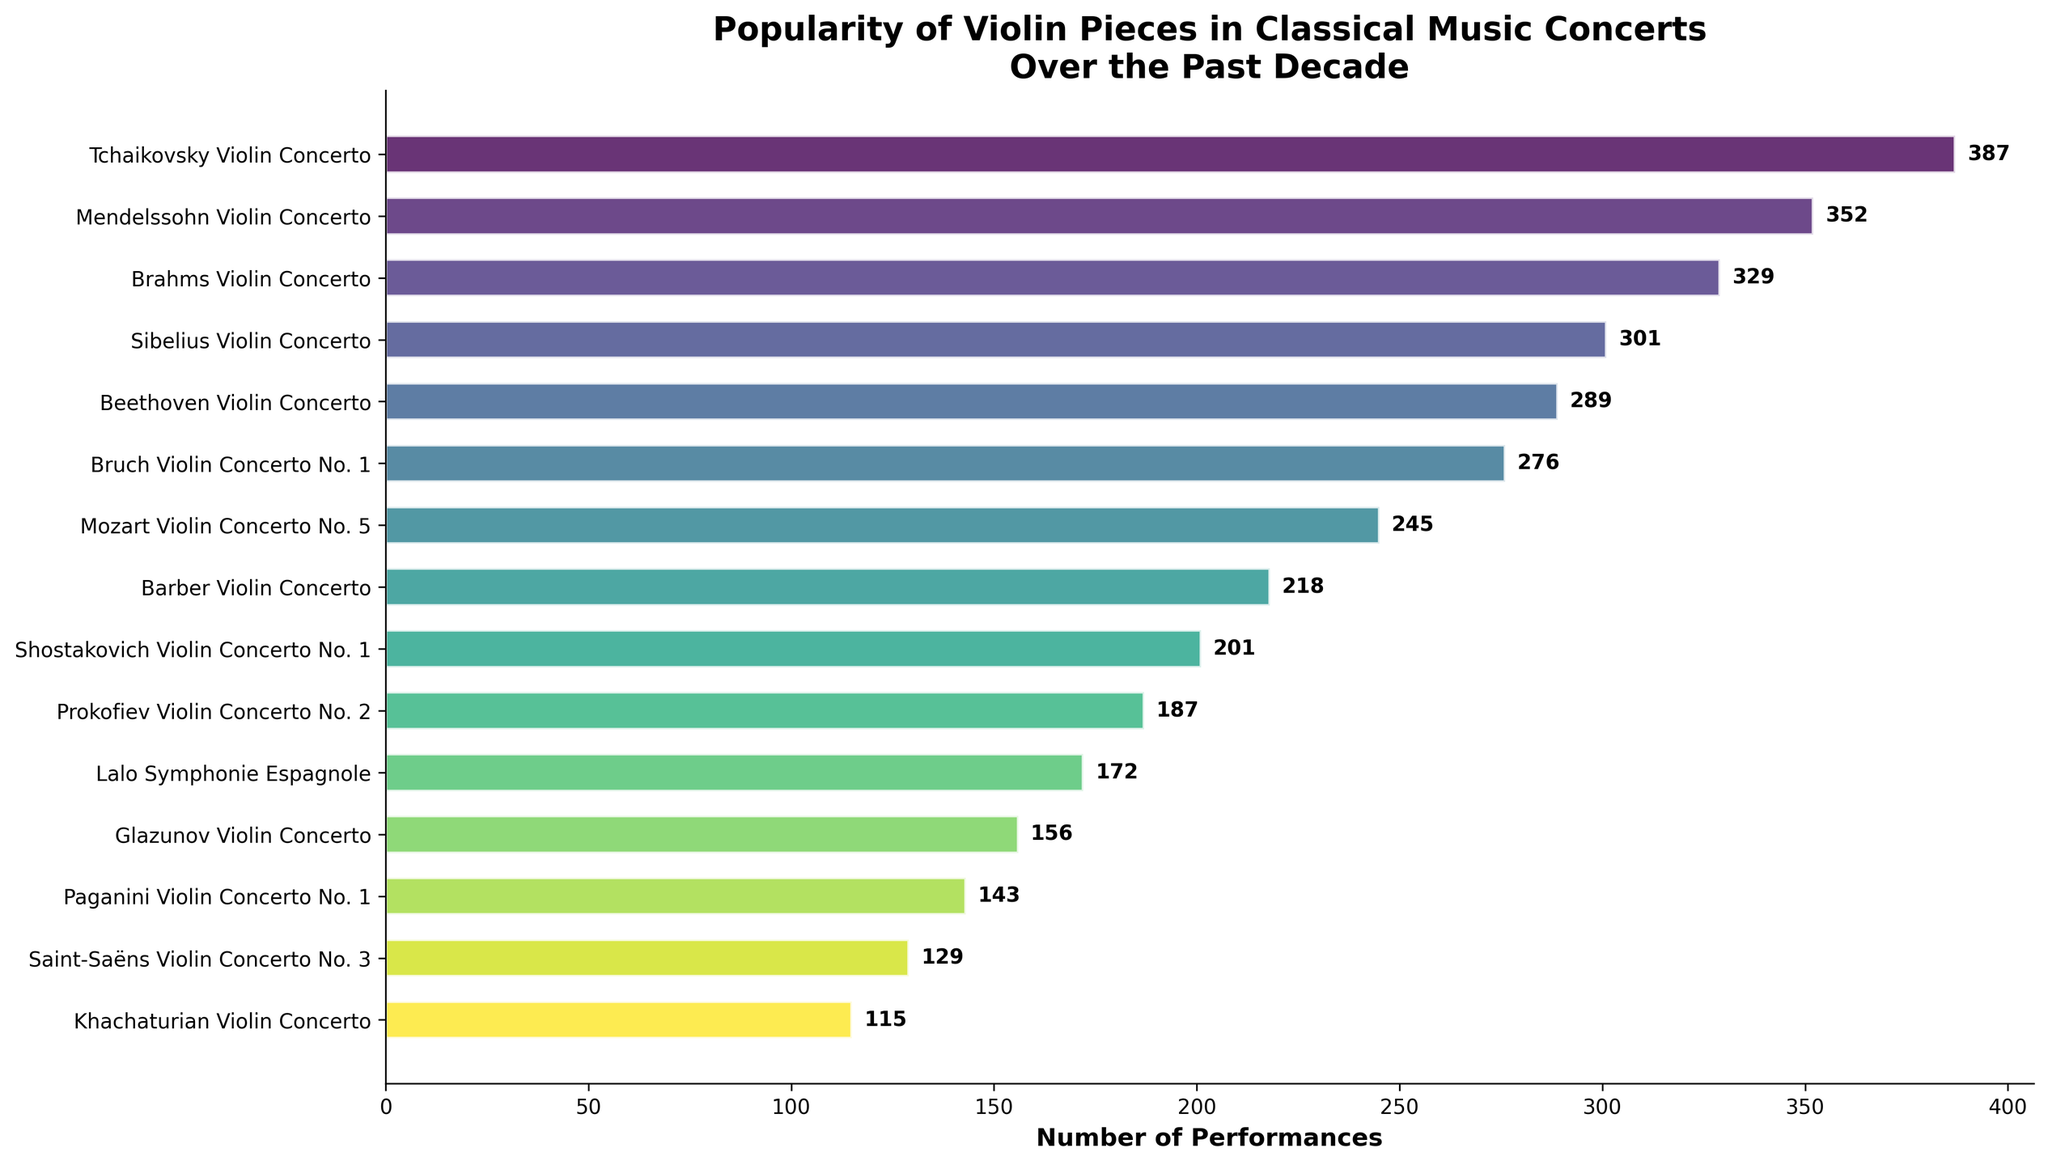What's the total number of performances for the top 3 most popular pieces? Sum the number of performances for the Tchaikovsky, Mendelssohn, and Brahms Violin Concertos: 387 + 352 + 329 = 1068
Answer: 1068 Which piece had the fewest performances? The piece with the fewest performances is the one at the bottom of the bar chart with the shortest bar. The Khachaturian Violin Concerto has the fewest performances.
Answer: Khachaturian Violin Concerto How many more performances does the Tchaikovsky Violin Concerto have compared to the Beethoven Violin Concerto? Subtract the number of performances of the Beethoven Violin Concerto from the Tchaikovsky Violin Concerto: 387 - 289 = 98
Answer: 98 What is the average number of performances of the listed pieces? Sum all the number of performances and then divide by the total number of pieces. The sum is 387 + 352 + 329 + 301 + 289 + 276 + 245 + 218 + 201 + 187 + 172 + 156 + 143 + 129 + 115 = 3800. The average is 3800 / 15 = 253.33
Answer: 253.33 Which concertos have more than 300 performances? Identify the concertos with bars extending beyond the 300 mark: Tchaikovsky, Mendelssohn, Brahms, Sibelius Violin Concertos.
Answer: Tchaikovsky, Mendelssohn, Brahms, Sibelius Violin Concertos How many violin concertos have fewer than 200 performances? Count the pieces with bars that do not reach the 200 mark: Shostakovich, Prokofiev, Lalo, Glazunov, Paganini, Saint-Saëns, Khachaturian Violin Concertos. This gives 7 pieces.
Answer: 7 Is the number of performances of the Mendelssohn Violin Concerto closer to that of the Brahms Violin Concerto or the Tchaikovsky Violin Concerto? Calculate the difference in the number of performances: For Tchaikovsky: 387 - 352 = 35; for Brahms: 352 - 329 = 23. The Mendelssohn Violin Concerto is closer to the Brahms Violin Concerto.
Answer: Brahms Violin Concerto What is the color gradient used in the bar chart? Observe and describe the color of the bars which transition from greenish-yellow to blue indicating a gradient.
Answer: greenish-yellow to blue 